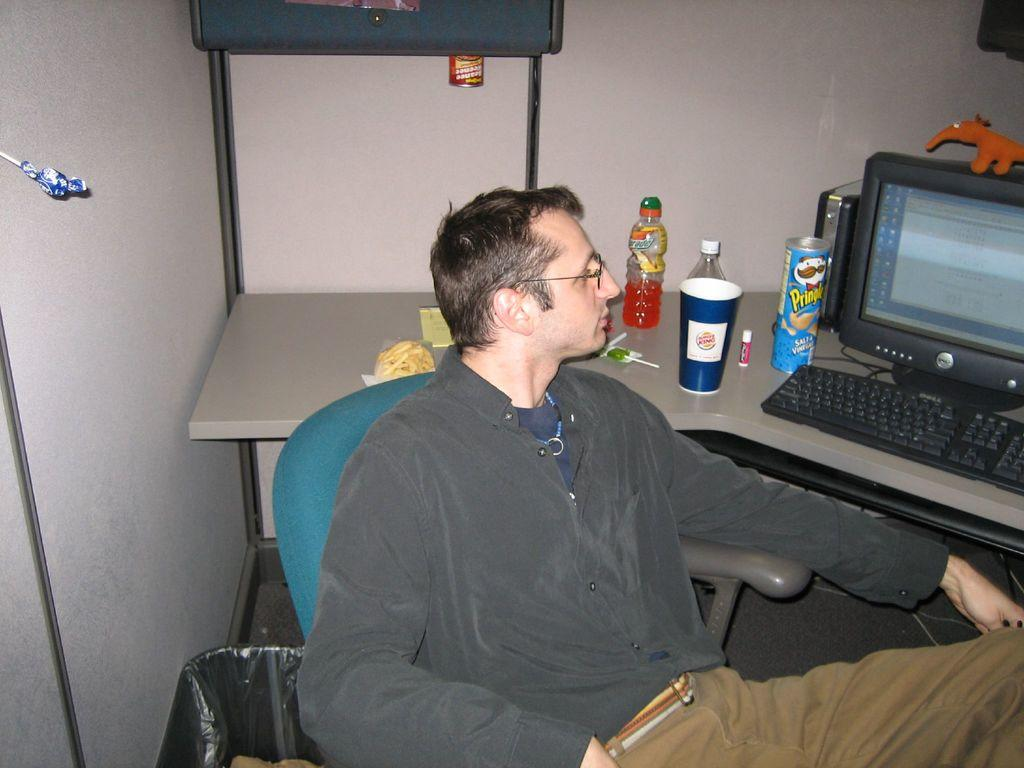<image>
Create a compact narrative representing the image presented. The cup on the counter is by Burger King 